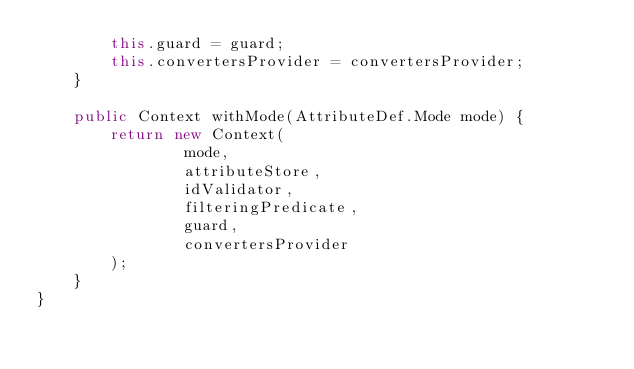Convert code to text. <code><loc_0><loc_0><loc_500><loc_500><_Java_>        this.guard = guard;
        this.convertersProvider = convertersProvider;
    }

    public Context withMode(AttributeDef.Mode mode) {
        return new Context(
                mode,
                attributeStore,
                idValidator,
                filteringPredicate,
                guard,
                convertersProvider
        );
    }
}
</code> 